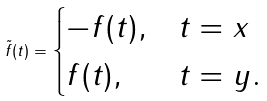<formula> <loc_0><loc_0><loc_500><loc_500>\tilde { f } ( t ) = \begin{cases} - f ( t ) , & t = x \\ f ( t ) , & t = y . \end{cases}</formula> 